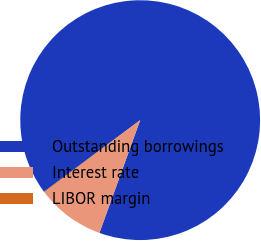Convert chart. <chart><loc_0><loc_0><loc_500><loc_500><pie_chart><fcel>Outstanding borrowings<fcel>Interest rate<fcel>LIBOR margin<nl><fcel>90.71%<fcel>9.18%<fcel>0.12%<nl></chart> 